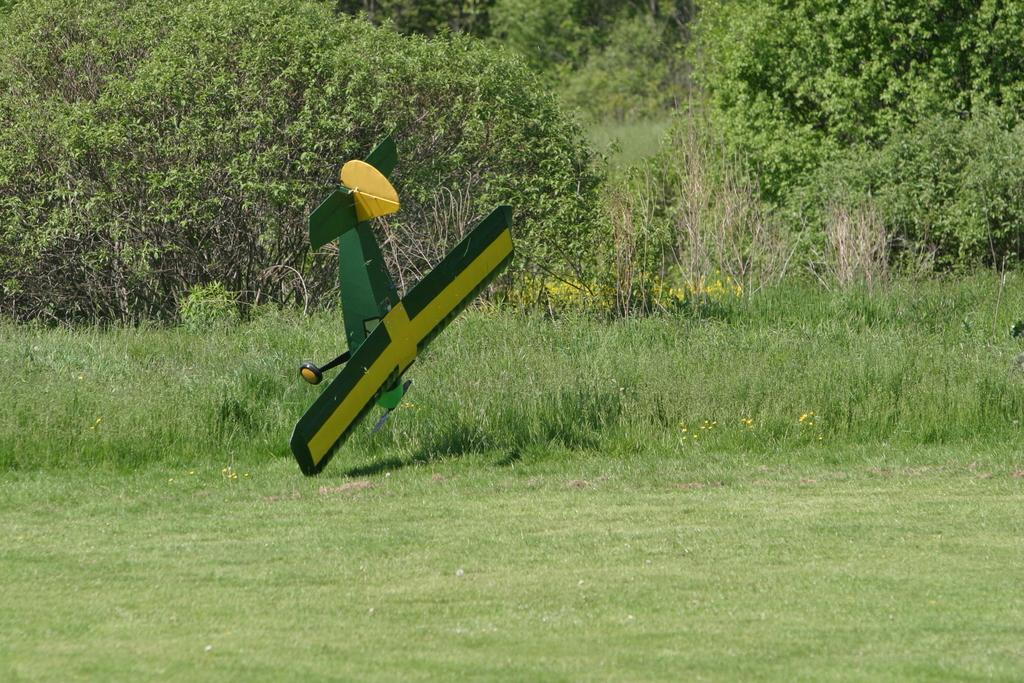What type of setting is depicted in the image? The image is an outside view. What can be seen on the ground in the image? There is a green color plane on the ground. What type of vegetation is visible in the background of the image? There is grass and trees in the background of the image. What direction is the note blowing in the image? There is no note present in the image, so it cannot be determined which direction it would blow. 